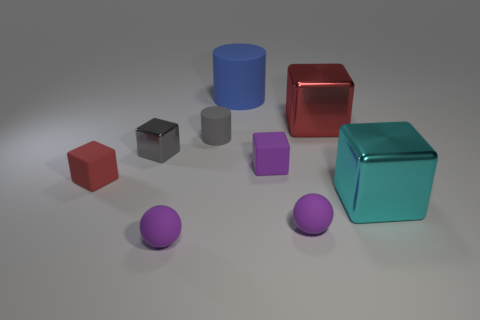Subtract 1 cubes. How many cubes are left? 4 Subtract all gray metal blocks. How many blocks are left? 4 Subtract all gray blocks. How many blocks are left? 4 Subtract all blue blocks. Subtract all brown spheres. How many blocks are left? 5 Add 1 tiny purple cubes. How many objects exist? 10 Subtract all cylinders. How many objects are left? 7 Subtract 0 cyan spheres. How many objects are left? 9 Subtract all tiny red matte cubes. Subtract all small gray things. How many objects are left? 6 Add 2 rubber objects. How many rubber objects are left? 8 Add 7 gray metal objects. How many gray metal objects exist? 8 